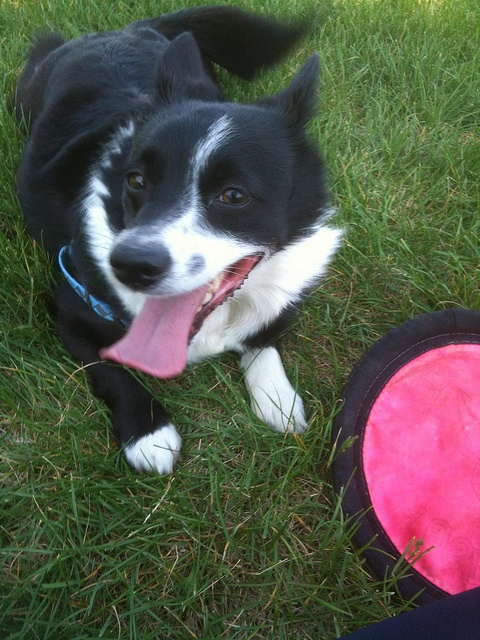Describe the objects in this image and their specific colors. I can see dog in green, black, white, and gray tones and frisbee in green, violet, black, and brown tones in this image. 